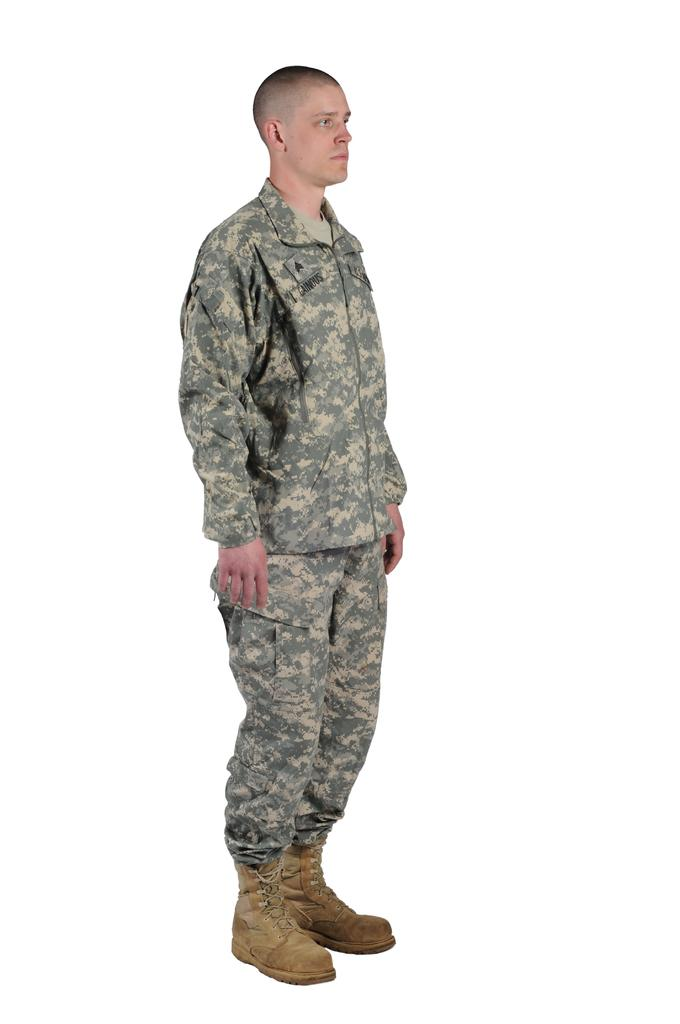What is the main subject of the image? There is a person standing in the image. What can be observed about the background of the image? The background of the image is white. How many animals are present in the zoo depicted in the image? There is no zoo present in the image; it features a person standing against a white background. 